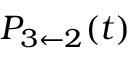Convert formula to latex. <formula><loc_0><loc_0><loc_500><loc_500>P _ { 3 \leftarrow 2 } ( t )</formula> 